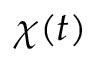<formula> <loc_0><loc_0><loc_500><loc_500>\chi ( t )</formula> 